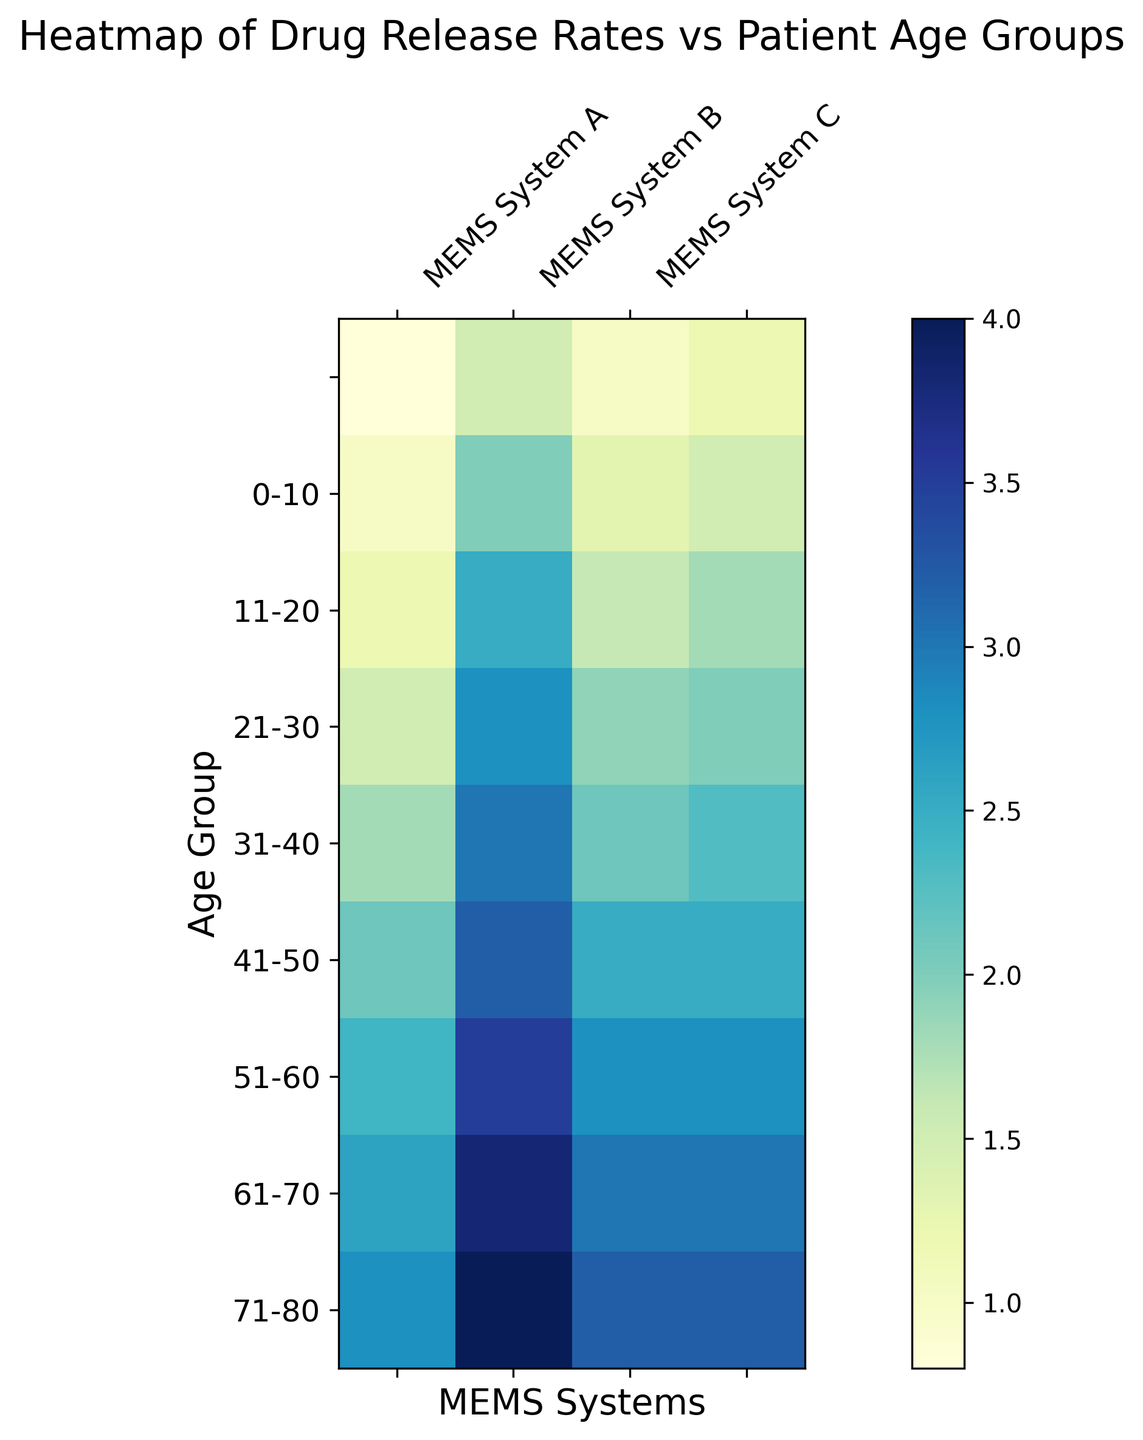What's the difference in drug release rates for MEMS System B between age groups 0-10 and 81-90? The heatmap shows that MEMS System B has a release rate of 1.5 for age group 0-10 and 4.0 for age group 81-90. The difference is calculated as 4.0 - 1.5 = 2.5.
Answer: 2.5 Which MEMS system shows the maximum increase in drug release rate from age group 0-10 to age group 81-90? The differences in drug release rates between age groups 0-10 and 81-90 are: MEMS System A: 2.8 - 0.8 = 2.0, MEMS System B: 4.0 - 1.5 = 2.5, MEMS System C: 3.2 - 1.0 = 2.2, MEMS System D: 3.2 - 1.2 = 2.0. MEMS System B shows the maximum increase.
Answer: MEMS System B What is the average drug release rate for age group 31-40 across all MEMS systems? The drug release rates for age group 31-40 are: MEMS System A: 1.5, MEMS System B: 2.8, MEMS System C: 1.9, MEMS System D: 2.0. The average is (1.5 + 2.8 + 1.9 + 2.0) / 4 = 2.05.
Answer: 2.05 In which age group does MEMS System A show its lowest drug release rate? The release rates for MEMS System A are: 0-10: 0.8, 11-20: 1.0, 21-30: 1.2, 31-40: 1.5, 41-50: 1.8, 51-60: 2.1, 61-70: 2.4, 71-80: 2.6, 81-90: 2.8. The lowest rate is 0.8 in the 0-10 age group.
Answer: 0-10 What color represents the highest drug release rate for MEMS System D? The highest drug release rate for MEMS System D is 3.2, which appears in the 81-90 age group. This location on the heatmap is in the top right, and it corresponds to a darker blue color.
Answer: Darker blue Compare the drug release rates between MEMS System A and MEMS System B for age group 51-60. Which is higher and by how much? For age group 51-60, MEMS System A has a release rate of 2.1 and MEMS System B has a release rate of 3.2. MEMS System B's rate is higher by 3.2 - 2.1 = 1.1.
Answer: MEMS System B by 1.1 What is the median drug release rate for MEMS System C across all age groups? The release rates for MEMS System C are: 1.0, 1.3, 1.6, 1.9, 2.1, 2.5, 2.8, 3.0, 3.2. The median value, being the middle value in an ordered list, is 2.1.
Answer: 2.1 